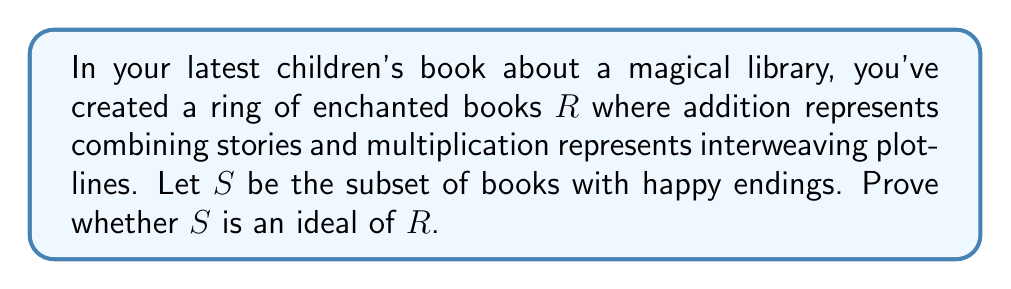What is the answer to this math problem? To prove whether $S$ is an ideal of $R$, we need to check if it satisfies the following conditions:

1. $S$ is a subgroup of $(R,+)$
2. For all $r \in R$ and $s \in S$, both $rs \in S$ and $sr \in S$

Let's examine each condition:

1. Subgroup condition:
   a) Closure under addition: If $a,b \in S$, then $a+b$ should be in $S$. 
      This means combining two books with happy endings should result in a book with a happy ending, which is reasonable.
   b) Additive inverse: For every $a \in S$, $-a$ should be in $S$. 
      This is where the ideal condition fails. The inverse of a happy ending would be a sad ending, which is not in $S$.

2. Absorption condition:
   For all $r \in R$ and $s \in S$, both $rs$ and $sr$ should be in $S$.
   This means interweaving any book's plot with a happy-ending book should always result in a happy-ending book. 
   This is not necessarily true, as the other book could have a strong enough unhappy element to change the overall ending.

Since both conditions are not satisfied, $S$ is not an ideal of $R$.
Answer: $S$ is not an ideal of $R$ because it fails to satisfy both the subgroup condition (lack of additive inverses) and the absorption condition. 